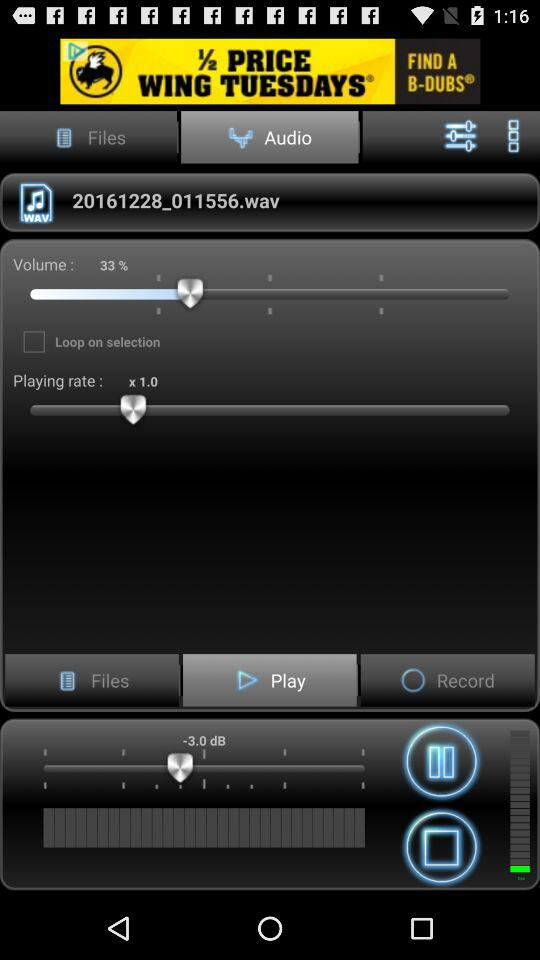What's the volume percentage? The volume is 33%. 